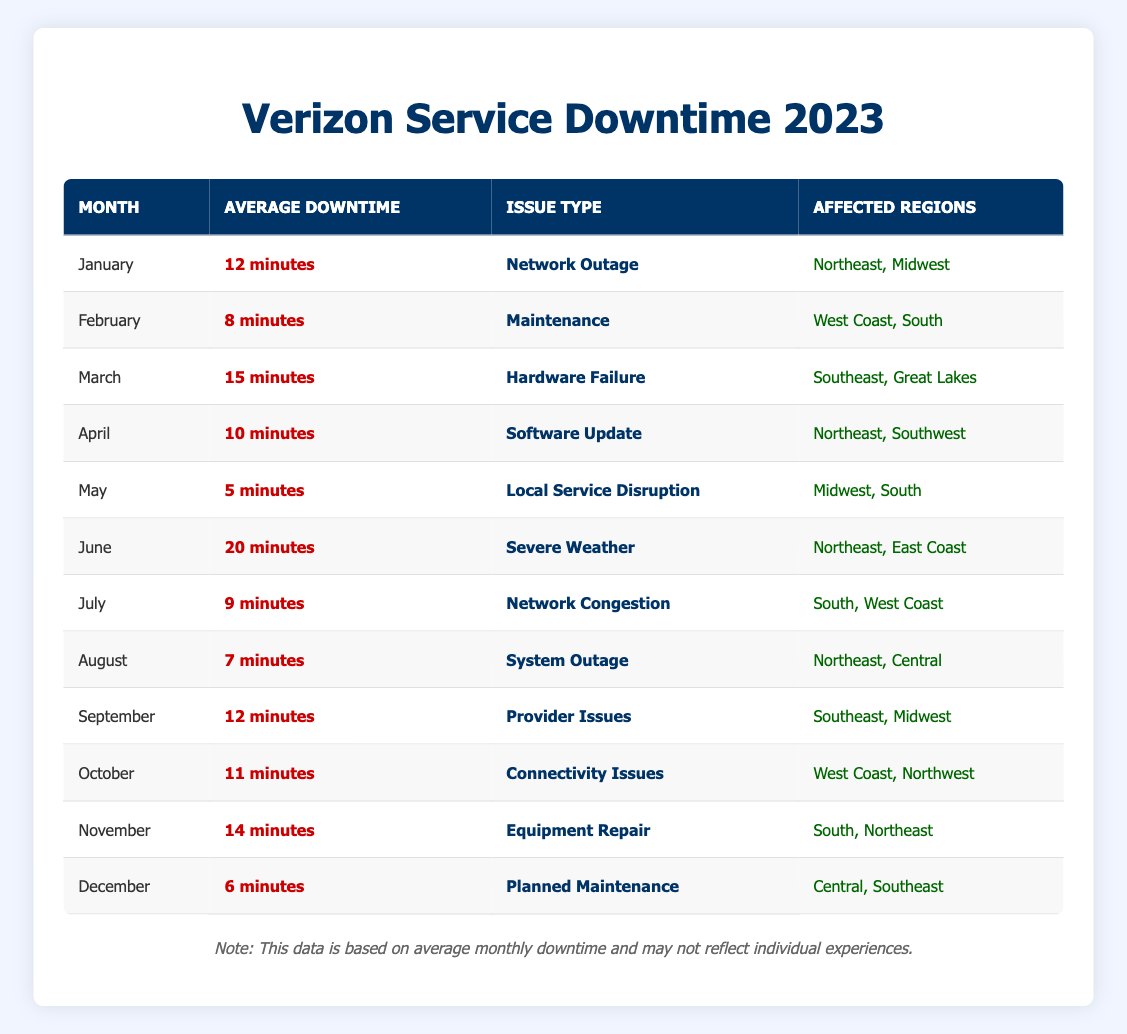What was the average downtime for June? The table indicates that in June, the average downtime was recorded as 20 minutes.
Answer: 20 minutes Which month experienced the least amount of downtime? By reviewing the table, May shows the lowest average downtime at 5 minutes.
Answer: May How many months had an average downtime of 10 minutes or more? Looking through the table, the months with 10 minutes or more are January, March, April, June, November, and October, totaling 6 months.
Answer: 6 Was there a month in 2023 where outages were caused by severe weather? According to the table, June had outages categorized under severe weather, confirming the fact.
Answer: Yes What is the difference in average downtime between March and April? March recorded an average downtime of 15 minutes, while April had 10 minutes. The difference can be calculated as 15 - 10 = 5 minutes.
Answer: 5 minutes Which issue type caused downtimes in both the Northeast and South regions? By examining the table, we see that the issue types “Network Outage” in January and “Software Update” in April affected both the Northeast and South regions.
Answer: Network Outage, Software Update What month had the highest average downtime? When checking the table, June is noted with the highest average downtime of 20 minutes.
Answer: June Which month had an average downtime of less than 10 minutes? The months with downtime under 10 minutes, as per the table, are May (5 minutes), February (8 minutes), and August (7 minutes).
Answer: May, February, August How does the average downtime in October compare to the average in November? The table displays October's average downtime at 11 minutes and November's at 14 minutes; therefore, November had 3 minutes more downtime than October.
Answer: November had 3 minutes more downtime 